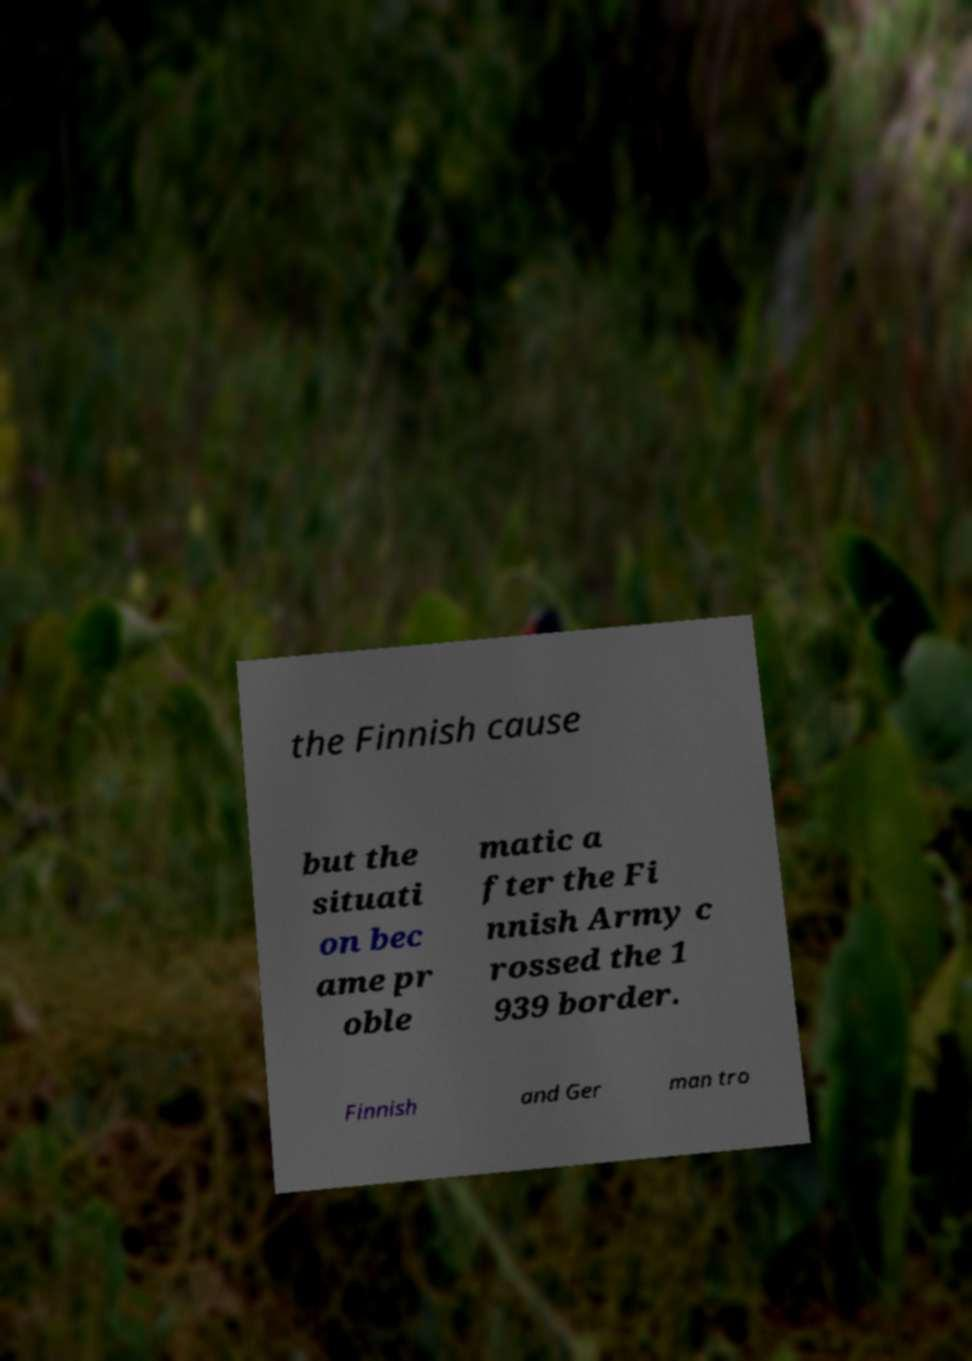What messages or text are displayed in this image? I need them in a readable, typed format. the Finnish cause but the situati on bec ame pr oble matic a fter the Fi nnish Army c rossed the 1 939 border. Finnish and Ger man tro 